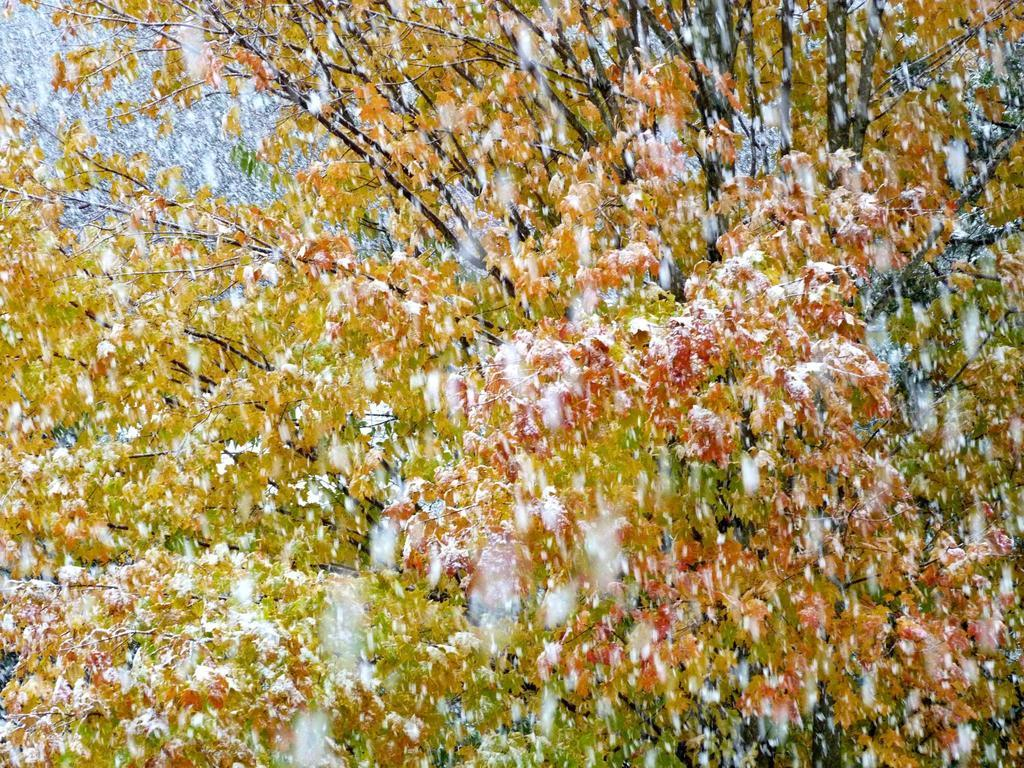What type of vegetation can be seen in the image? There are trees in the image. What type of pen can be seen being used to smash the trees in the image? There is no pen or any object being used to smash the trees in the image; the trees are standing undisturbed. 